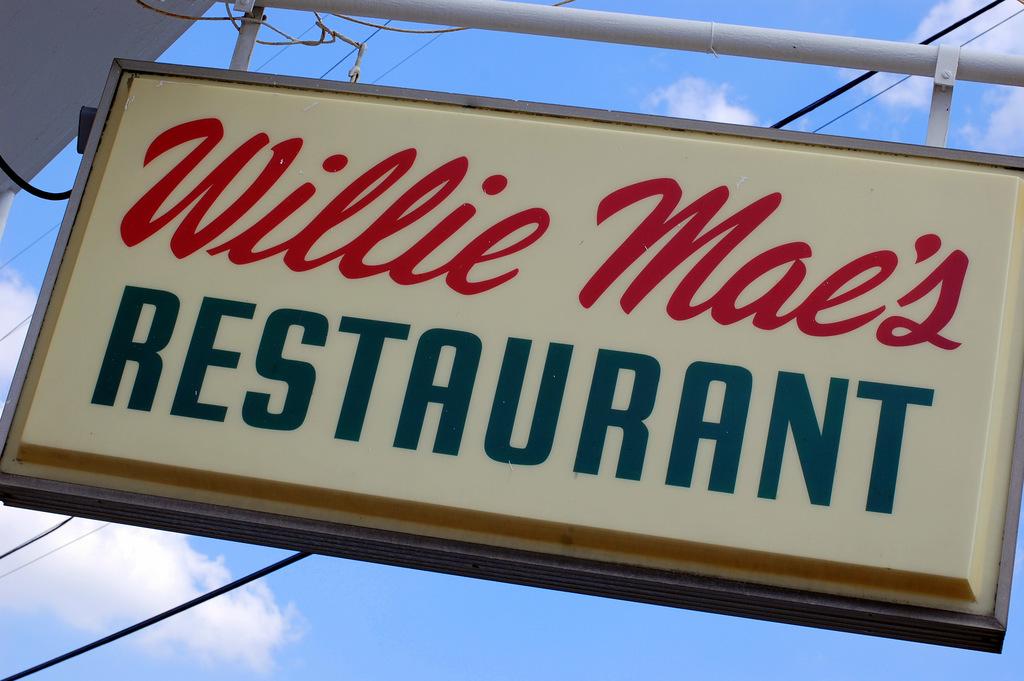What kind of establishment is willie mae's?
Provide a succinct answer. Restaurant. What is the name of the restaurant?
Your answer should be compact. Willie mae's. 